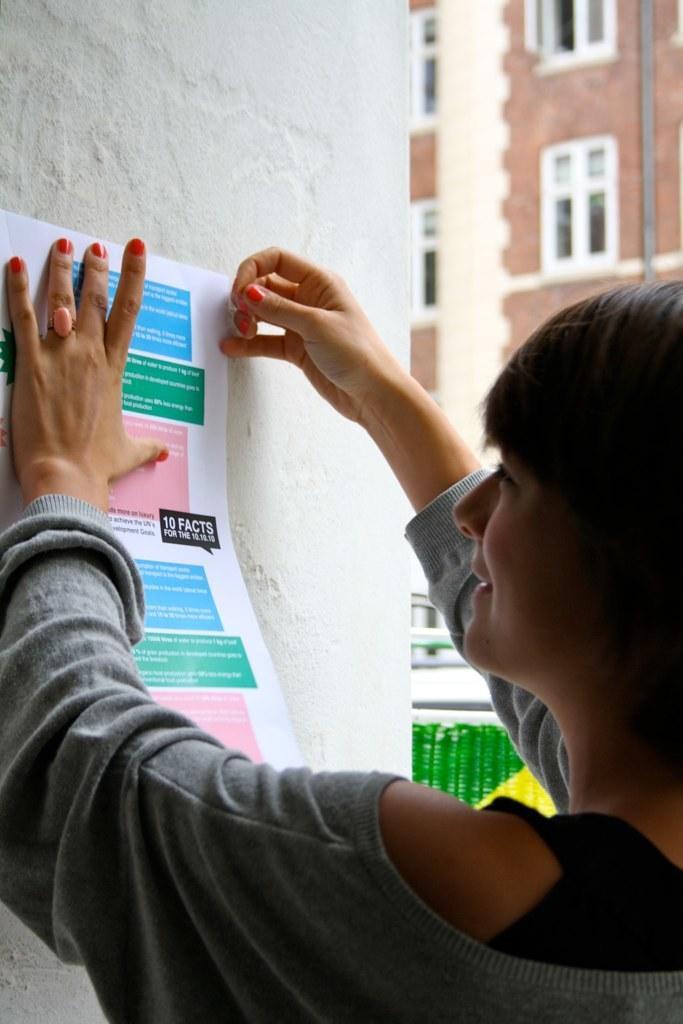Can you describe this image briefly? In this picture I can see a person holding a paper, which is on the wall, and in the background there is a building with windows. 